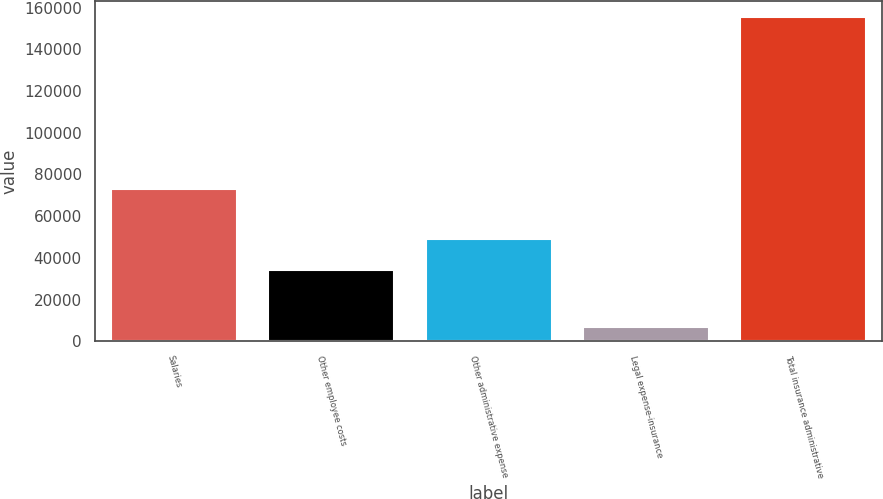Convert chart. <chart><loc_0><loc_0><loc_500><loc_500><bar_chart><fcel>Salaries<fcel>Other employee costs<fcel>Other administrative expense<fcel>Legal expense-insurance<fcel>Total insurance administrative<nl><fcel>73034<fcel>34109<fcel>48996.9<fcel>6736<fcel>155615<nl></chart> 